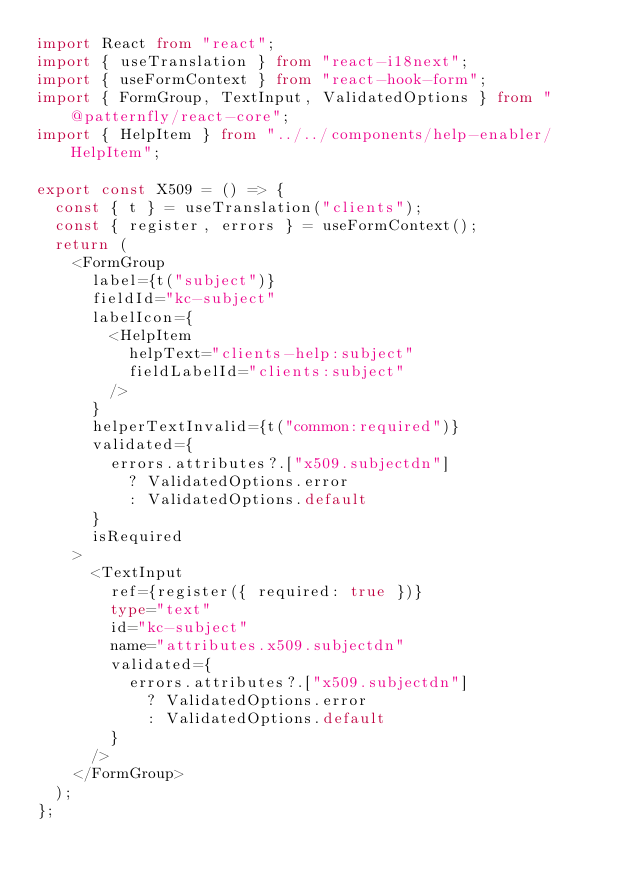Convert code to text. <code><loc_0><loc_0><loc_500><loc_500><_TypeScript_>import React from "react";
import { useTranslation } from "react-i18next";
import { useFormContext } from "react-hook-form";
import { FormGroup, TextInput, ValidatedOptions } from "@patternfly/react-core";
import { HelpItem } from "../../components/help-enabler/HelpItem";

export const X509 = () => {
  const { t } = useTranslation("clients");
  const { register, errors } = useFormContext();
  return (
    <FormGroup
      label={t("subject")}
      fieldId="kc-subject"
      labelIcon={
        <HelpItem
          helpText="clients-help:subject"
          fieldLabelId="clients:subject"
        />
      }
      helperTextInvalid={t("common:required")}
      validated={
        errors.attributes?.["x509.subjectdn"]
          ? ValidatedOptions.error
          : ValidatedOptions.default
      }
      isRequired
    >
      <TextInput
        ref={register({ required: true })}
        type="text"
        id="kc-subject"
        name="attributes.x509.subjectdn"
        validated={
          errors.attributes?.["x509.subjectdn"]
            ? ValidatedOptions.error
            : ValidatedOptions.default
        }
      />
    </FormGroup>
  );
};
</code> 